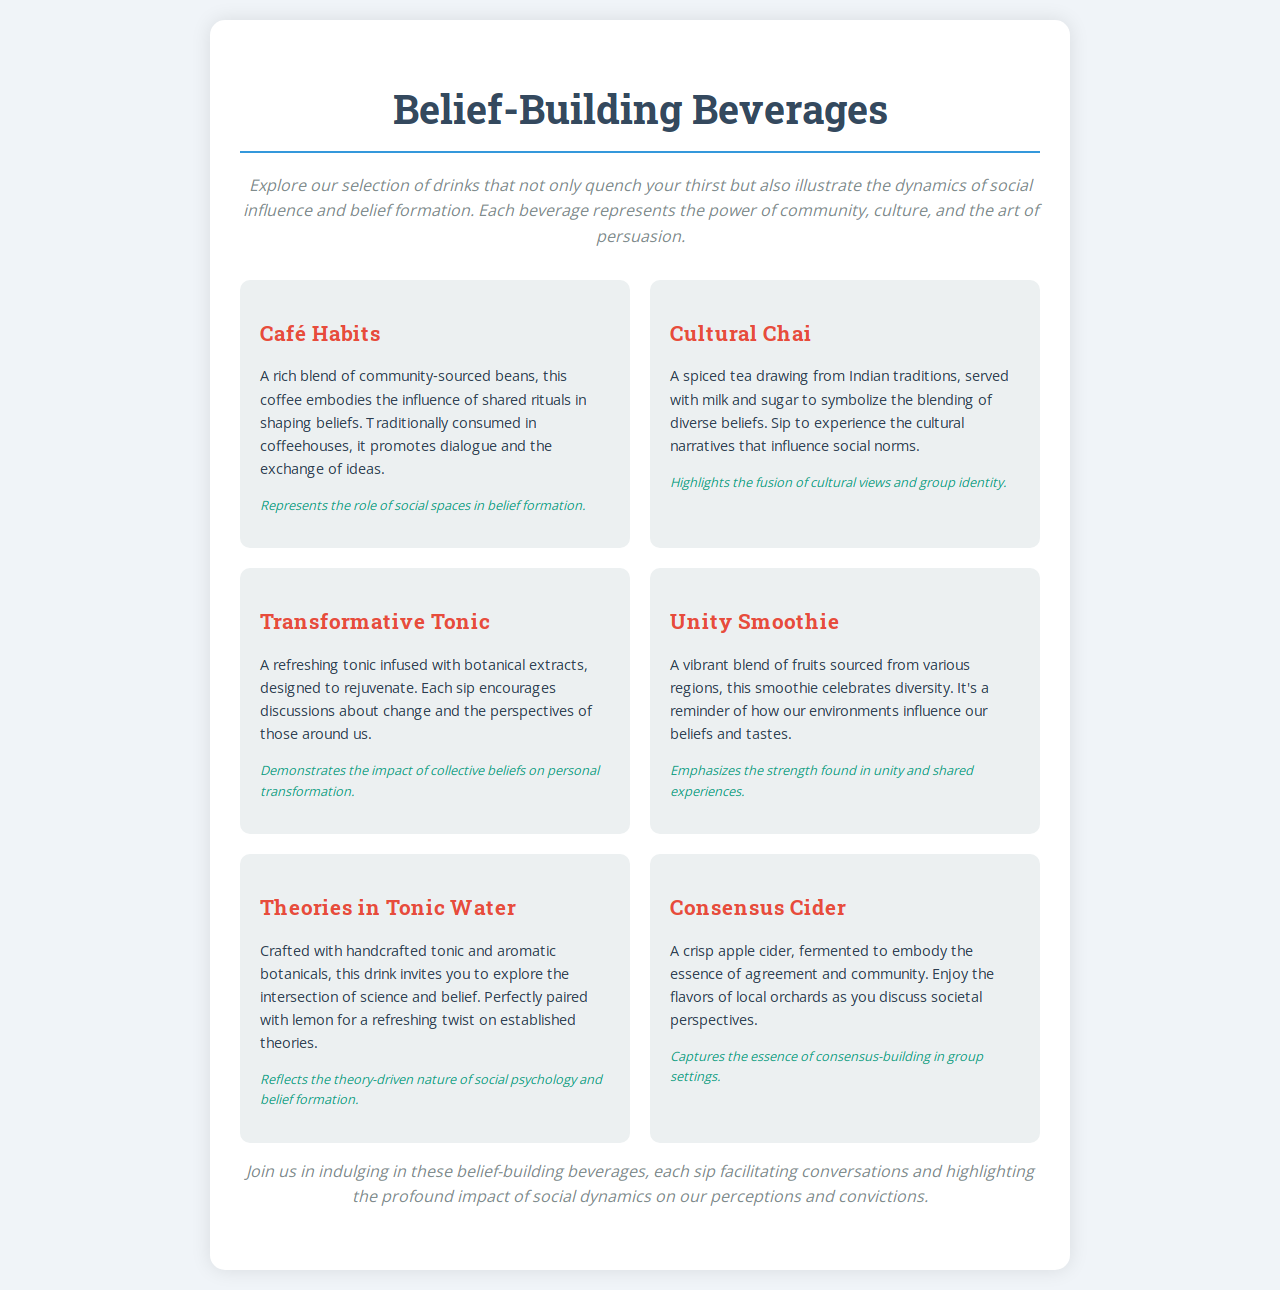What is the title of the menu? The title of the menu is the main heading presented at the top of the document.
Answer: Belief-Building Beverages How many beverages are listed on the menu? The number of beverages is determined by counting the distinct beverage items in the document.
Answer: Six What does "Café Habits" symbolize? The symbolism of "Café Habits" is found in the description of its influence on belief formation.
Answer: The role of social spaces in belief formation What beverage is described as a blend of fruits? This can be found in the item that includes a vibrant blend of fruits in its description.
Answer: Unity Smoothie What is the main ingredient in "Cultural Chai"? The specific ingredient contributing to the identity of "Cultural Chai" is part of its description.
Answer: Spiced tea Which beverage represents collective beliefs on personal transformation? This requires connecting the description of each drink to its symbolism regarding belief transformation.
Answer: Transformative Tonic What is served with the "Theories in Tonic Water" for a refreshing twist? This detail specifies an additional ingredient that enhances the beverage experience.
Answer: Lemon What type of drink is "Consensus Cider"? The category of the drink is based on its description of the main component.
Answer: Apple cider 